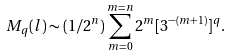<formula> <loc_0><loc_0><loc_500><loc_500>M _ { q } ( l ) \sim ( 1 / 2 ^ { n } ) \sum _ { m = 0 } ^ { m = n } 2 ^ { m } [ 3 ^ { - ( m + 1 ) } ] ^ { q } .</formula> 